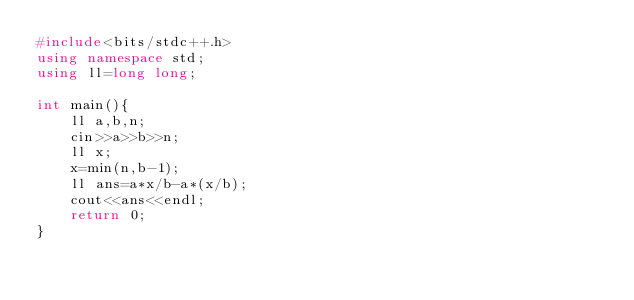<code> <loc_0><loc_0><loc_500><loc_500><_C++_>#include<bits/stdc++.h>
using namespace std;
using ll=long long;

int main(){
    ll a,b,n;
    cin>>a>>b>>n;
    ll x;
    x=min(n,b-1);
    ll ans=a*x/b-a*(x/b);
    cout<<ans<<endl;
    return 0;
}</code> 